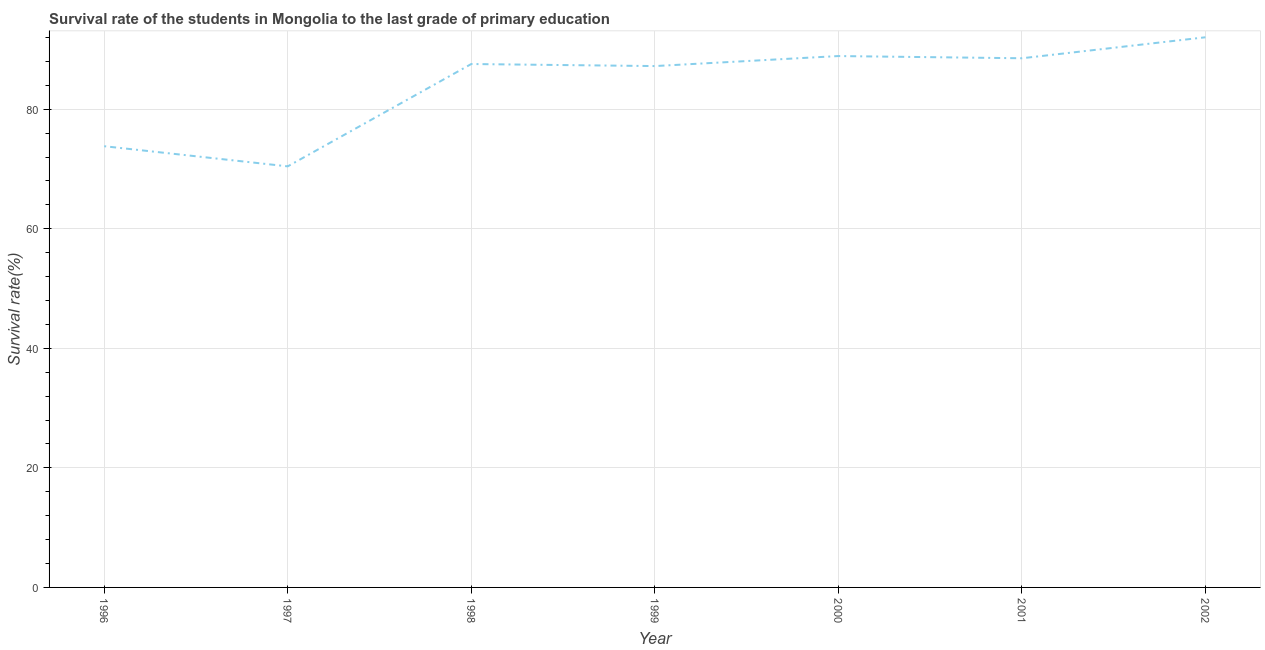What is the survival rate in primary education in 2001?
Offer a very short reply. 88.53. Across all years, what is the maximum survival rate in primary education?
Ensure brevity in your answer.  92.04. Across all years, what is the minimum survival rate in primary education?
Provide a succinct answer. 70.45. What is the sum of the survival rate in primary education?
Provide a succinct answer. 588.51. What is the difference between the survival rate in primary education in 2001 and 2002?
Your answer should be very brief. -3.51. What is the average survival rate in primary education per year?
Provide a succinct answer. 84.07. What is the median survival rate in primary education?
Offer a very short reply. 87.56. In how many years, is the survival rate in primary education greater than 36 %?
Ensure brevity in your answer.  7. Do a majority of the years between 1996 and 1997 (inclusive) have survival rate in primary education greater than 48 %?
Offer a very short reply. Yes. What is the ratio of the survival rate in primary education in 1997 to that in 2002?
Provide a short and direct response. 0.77. What is the difference between the highest and the second highest survival rate in primary education?
Offer a terse response. 3.14. What is the difference between the highest and the lowest survival rate in primary education?
Your answer should be very brief. 21.59. In how many years, is the survival rate in primary education greater than the average survival rate in primary education taken over all years?
Your answer should be compact. 5. Does the survival rate in primary education monotonically increase over the years?
Provide a succinct answer. No. How many lines are there?
Your answer should be compact. 1. How many years are there in the graph?
Make the answer very short. 7. What is the difference between two consecutive major ticks on the Y-axis?
Ensure brevity in your answer.  20. Does the graph contain any zero values?
Give a very brief answer. No. What is the title of the graph?
Provide a short and direct response. Survival rate of the students in Mongolia to the last grade of primary education. What is the label or title of the X-axis?
Your response must be concise. Year. What is the label or title of the Y-axis?
Offer a terse response. Survival rate(%). What is the Survival rate(%) of 1996?
Offer a terse response. 73.82. What is the Survival rate(%) of 1997?
Offer a terse response. 70.45. What is the Survival rate(%) of 1998?
Your response must be concise. 87.56. What is the Survival rate(%) in 1999?
Give a very brief answer. 87.22. What is the Survival rate(%) of 2000?
Make the answer very short. 88.9. What is the Survival rate(%) in 2001?
Offer a very short reply. 88.53. What is the Survival rate(%) in 2002?
Give a very brief answer. 92.04. What is the difference between the Survival rate(%) in 1996 and 1997?
Your answer should be compact. 3.37. What is the difference between the Survival rate(%) in 1996 and 1998?
Give a very brief answer. -13.75. What is the difference between the Survival rate(%) in 1996 and 1999?
Offer a terse response. -13.41. What is the difference between the Survival rate(%) in 1996 and 2000?
Make the answer very short. -15.08. What is the difference between the Survival rate(%) in 1996 and 2001?
Provide a short and direct response. -14.71. What is the difference between the Survival rate(%) in 1996 and 2002?
Offer a terse response. -18.22. What is the difference between the Survival rate(%) in 1997 and 1998?
Provide a short and direct response. -17.12. What is the difference between the Survival rate(%) in 1997 and 1999?
Give a very brief answer. -16.78. What is the difference between the Survival rate(%) in 1997 and 2000?
Provide a short and direct response. -18.45. What is the difference between the Survival rate(%) in 1997 and 2001?
Ensure brevity in your answer.  -18.08. What is the difference between the Survival rate(%) in 1997 and 2002?
Provide a succinct answer. -21.59. What is the difference between the Survival rate(%) in 1998 and 1999?
Offer a very short reply. 0.34. What is the difference between the Survival rate(%) in 1998 and 2000?
Keep it short and to the point. -1.33. What is the difference between the Survival rate(%) in 1998 and 2001?
Your answer should be very brief. -0.96. What is the difference between the Survival rate(%) in 1998 and 2002?
Keep it short and to the point. -4.47. What is the difference between the Survival rate(%) in 1999 and 2000?
Your answer should be very brief. -1.68. What is the difference between the Survival rate(%) in 1999 and 2001?
Offer a very short reply. -1.31. What is the difference between the Survival rate(%) in 1999 and 2002?
Your answer should be compact. -4.82. What is the difference between the Survival rate(%) in 2000 and 2001?
Provide a succinct answer. 0.37. What is the difference between the Survival rate(%) in 2000 and 2002?
Offer a terse response. -3.14. What is the difference between the Survival rate(%) in 2001 and 2002?
Provide a short and direct response. -3.51. What is the ratio of the Survival rate(%) in 1996 to that in 1997?
Make the answer very short. 1.05. What is the ratio of the Survival rate(%) in 1996 to that in 1998?
Offer a terse response. 0.84. What is the ratio of the Survival rate(%) in 1996 to that in 1999?
Your answer should be compact. 0.85. What is the ratio of the Survival rate(%) in 1996 to that in 2000?
Make the answer very short. 0.83. What is the ratio of the Survival rate(%) in 1996 to that in 2001?
Keep it short and to the point. 0.83. What is the ratio of the Survival rate(%) in 1996 to that in 2002?
Provide a succinct answer. 0.8. What is the ratio of the Survival rate(%) in 1997 to that in 1998?
Your answer should be very brief. 0.8. What is the ratio of the Survival rate(%) in 1997 to that in 1999?
Keep it short and to the point. 0.81. What is the ratio of the Survival rate(%) in 1997 to that in 2000?
Offer a very short reply. 0.79. What is the ratio of the Survival rate(%) in 1997 to that in 2001?
Provide a short and direct response. 0.8. What is the ratio of the Survival rate(%) in 1997 to that in 2002?
Ensure brevity in your answer.  0.77. What is the ratio of the Survival rate(%) in 1998 to that in 2001?
Your answer should be very brief. 0.99. What is the ratio of the Survival rate(%) in 1998 to that in 2002?
Offer a very short reply. 0.95. What is the ratio of the Survival rate(%) in 1999 to that in 2001?
Provide a short and direct response. 0.98. What is the ratio of the Survival rate(%) in 1999 to that in 2002?
Make the answer very short. 0.95. What is the ratio of the Survival rate(%) in 2000 to that in 2002?
Your response must be concise. 0.97. What is the ratio of the Survival rate(%) in 2001 to that in 2002?
Make the answer very short. 0.96. 